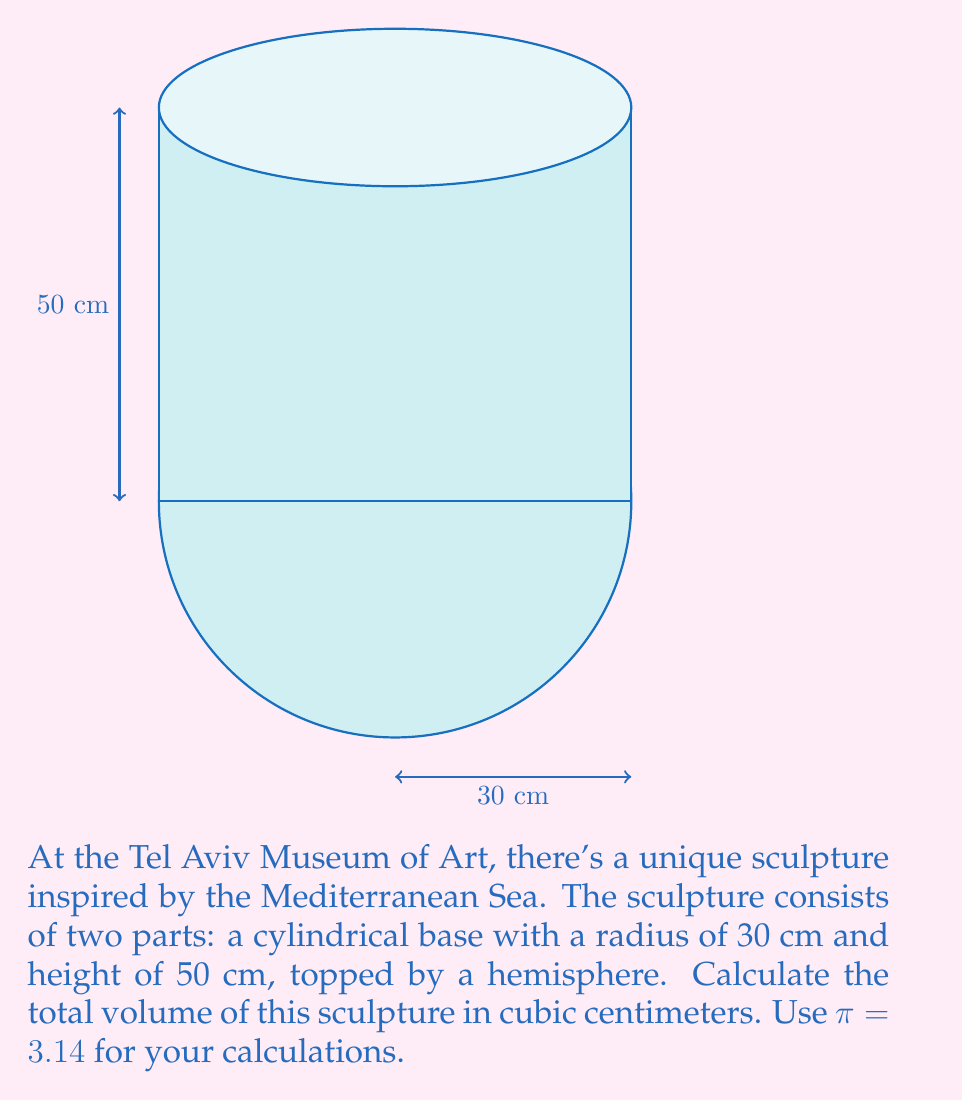Help me with this question. Let's approach this problem step-by-step:

1) The sculpture consists of two parts: a cylinder and a hemisphere. We need to calculate the volume of each part and then add them together.

2) Volume of the cylinder:
   The formula for the volume of a cylinder is $V_c = \pi r^2 h$
   where $r$ is the radius and $h$ is the height.
   $$V_c = 3.14 \times 30^2 \times 50 = 3.14 \times 900 \times 50 = 141,300 \text{ cm}^3$$

3) Volume of the hemisphere:
   The formula for the volume of a sphere is $V_s = \frac{4}{3}\pi r^3$
   A hemisphere is half of this, so $V_h = \frac{1}{2} \times \frac{4}{3}\pi r^3 = \frac{2}{3}\pi r^3$
   $$V_h = \frac{2}{3} \times 3.14 \times 30^3 = \frac{2}{3} \times 3.14 \times 27,000 = 56,520 \text{ cm}^3$$

4) Total volume:
   $$V_{\text{total}} = V_c + V_h = 141,300 + 56,520 = 197,820 \text{ cm}^3$$

Therefore, the total volume of the sculpture is 197,820 cubic centimeters.
Answer: 197,820 cm³ 